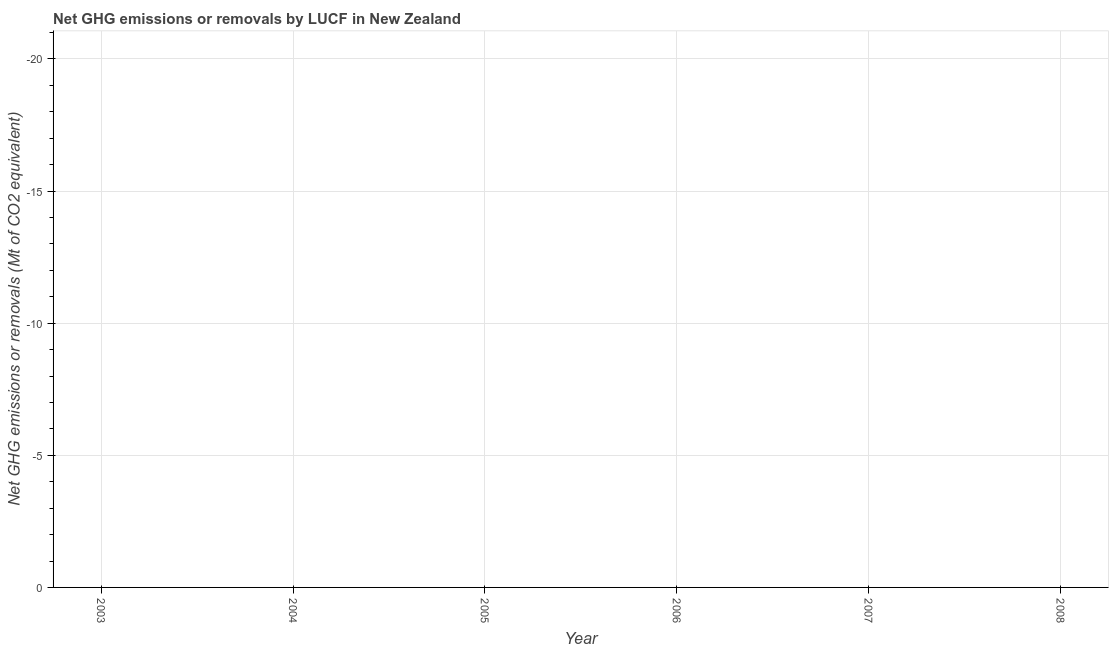What is the ghg net emissions or removals in 2008?
Ensure brevity in your answer.  0. Across all years, what is the minimum ghg net emissions or removals?
Offer a very short reply. 0. What is the sum of the ghg net emissions or removals?
Ensure brevity in your answer.  0. What is the median ghg net emissions or removals?
Ensure brevity in your answer.  0. In how many years, is the ghg net emissions or removals greater than the average ghg net emissions or removals taken over all years?
Keep it short and to the point. 0. Does the ghg net emissions or removals monotonically increase over the years?
Provide a short and direct response. No. How many dotlines are there?
Provide a short and direct response. 0. How many years are there in the graph?
Offer a terse response. 6. Does the graph contain any zero values?
Offer a very short reply. Yes. Does the graph contain grids?
Your answer should be very brief. Yes. What is the title of the graph?
Ensure brevity in your answer.  Net GHG emissions or removals by LUCF in New Zealand. What is the label or title of the Y-axis?
Your answer should be compact. Net GHG emissions or removals (Mt of CO2 equivalent). What is the Net GHG emissions or removals (Mt of CO2 equivalent) in 2005?
Ensure brevity in your answer.  0. What is the Net GHG emissions or removals (Mt of CO2 equivalent) in 2006?
Provide a short and direct response. 0. What is the Net GHG emissions or removals (Mt of CO2 equivalent) in 2007?
Provide a succinct answer. 0. What is the Net GHG emissions or removals (Mt of CO2 equivalent) in 2008?
Keep it short and to the point. 0. 